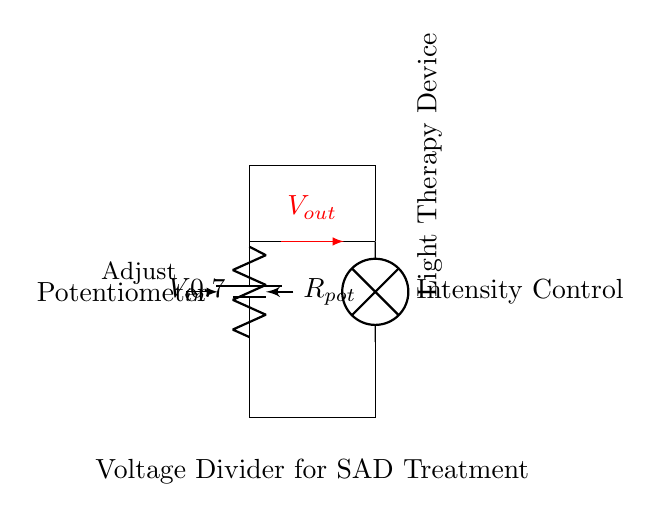What are the components in this circuit? The circuit consists of a battery as the power supply, a potentiometer for resistance adjustment, and a light therapy device (lamp) as the output load.
Answer: Battery, Potentiometer, Light Therapy Device What is the purpose of the potentiometer in this circuit? The potentiometer functions as a variable resistor to adjust the output voltage delivered to the light therapy device, allowing control over its intensity.
Answer: Intensity Control What is the role of the light therapy device in this setup? The light therapy device emits light that is used to treat seasonal affective disorder, relying on the adjusted voltage from the potentiometer for its operation.
Answer: Treat SAD How does adjusting the potentiometer affect the voltage output? Adjusting the potentiometer changes its resistance, which in turn modifies the voltage division in the circuit, increasing or decreasing the output voltage delivered to the light therapy device.
Answer: Changes voltage If the potentiometer is set to maximum resistance, what happens to the light intensity? When the potentiometer is set to maximum resistance, the output voltage to the light therapy device is minimized, resulting in reduced light intensity emitted by the device.
Answer: Reduced intensity What type of circuit is formed by the potentiometer and the light therapy device? The circuit is a voltage divider because the potentiometer creates a division of voltage between the input from the battery and the output to the light therapy device.
Answer: Voltage Divider 